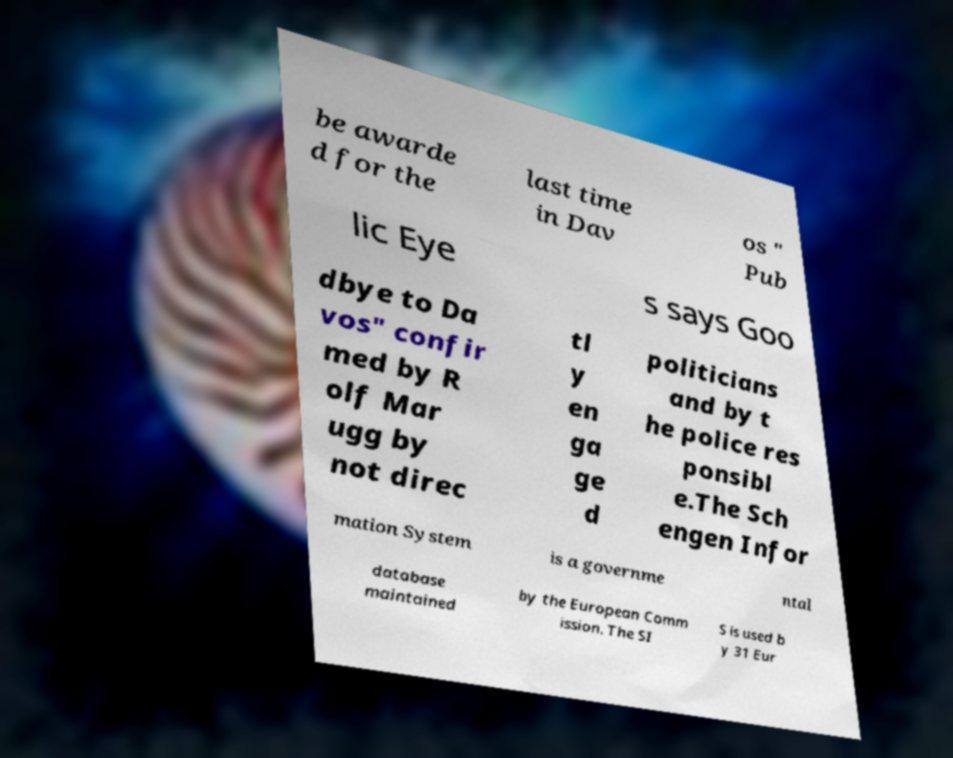Can you read and provide the text displayed in the image?This photo seems to have some interesting text. Can you extract and type it out for me? be awarde d for the last time in Dav os " Pub lic Eye s says Goo dbye to Da vos" confir med by R olf Mar ugg by not direc tl y en ga ge d politicians and by t he police res ponsibl e.The Sch engen Infor mation System is a governme ntal database maintained by the European Comm ission. The SI S is used b y 31 Eur 